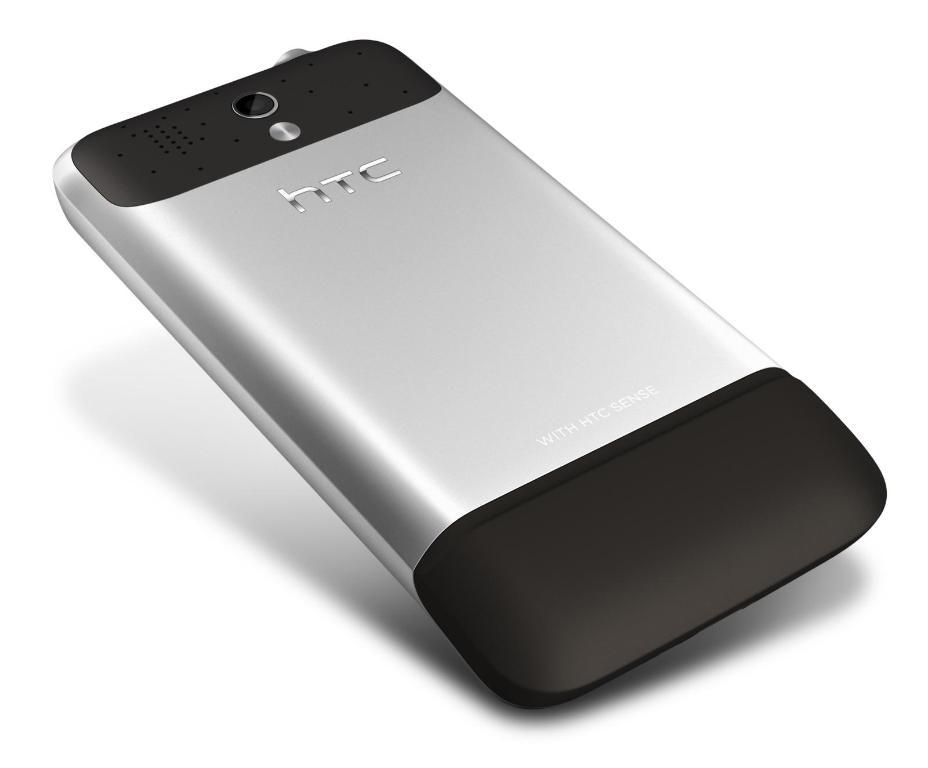What brand is this phone?
Your answer should be very brief. Htc. What statement is written at the bottom of the phone?
Offer a very short reply. With htc sense. 